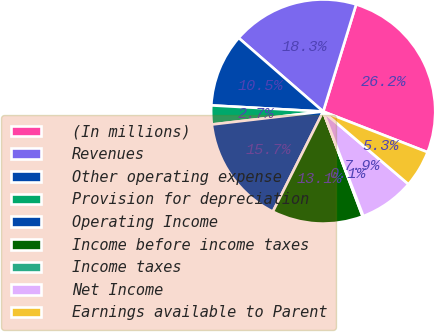<chart> <loc_0><loc_0><loc_500><loc_500><pie_chart><fcel>(In millions)<fcel>Revenues<fcel>Other operating expense<fcel>Provision for depreciation<fcel>Operating Income<fcel>Income before income taxes<fcel>Income taxes<fcel>Net Income<fcel>Earnings available to Parent<nl><fcel>26.16%<fcel>18.35%<fcel>10.53%<fcel>2.72%<fcel>15.74%<fcel>13.14%<fcel>0.11%<fcel>7.93%<fcel>5.32%<nl></chart> 